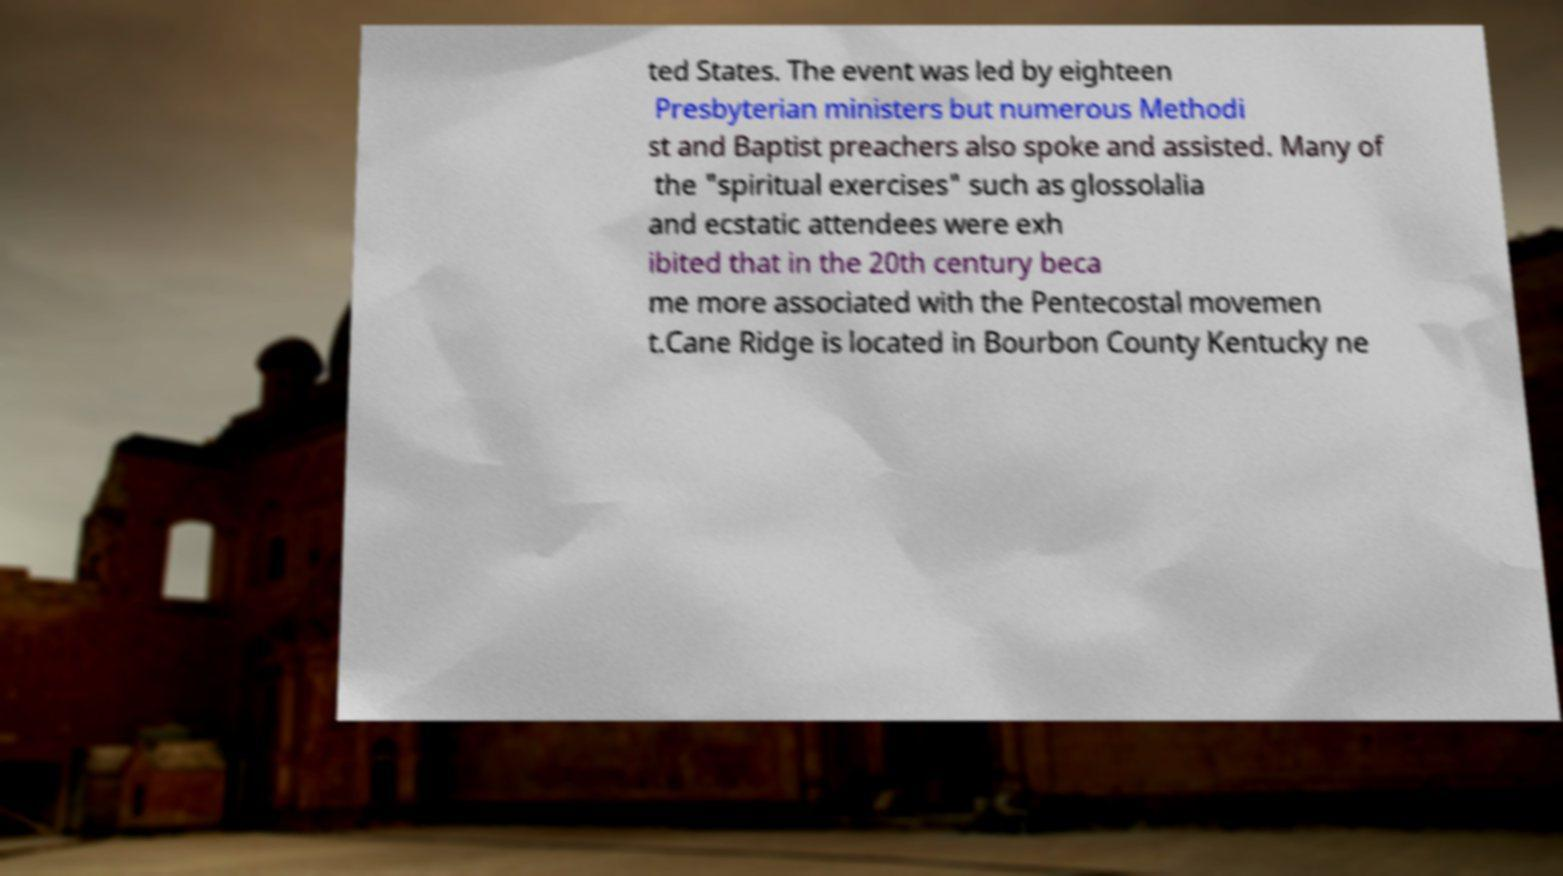I need the written content from this picture converted into text. Can you do that? ted States. The event was led by eighteen Presbyterian ministers but numerous Methodi st and Baptist preachers also spoke and assisted. Many of the "spiritual exercises" such as glossolalia and ecstatic attendees were exh ibited that in the 20th century beca me more associated with the Pentecostal movemen t.Cane Ridge is located in Bourbon County Kentucky ne 